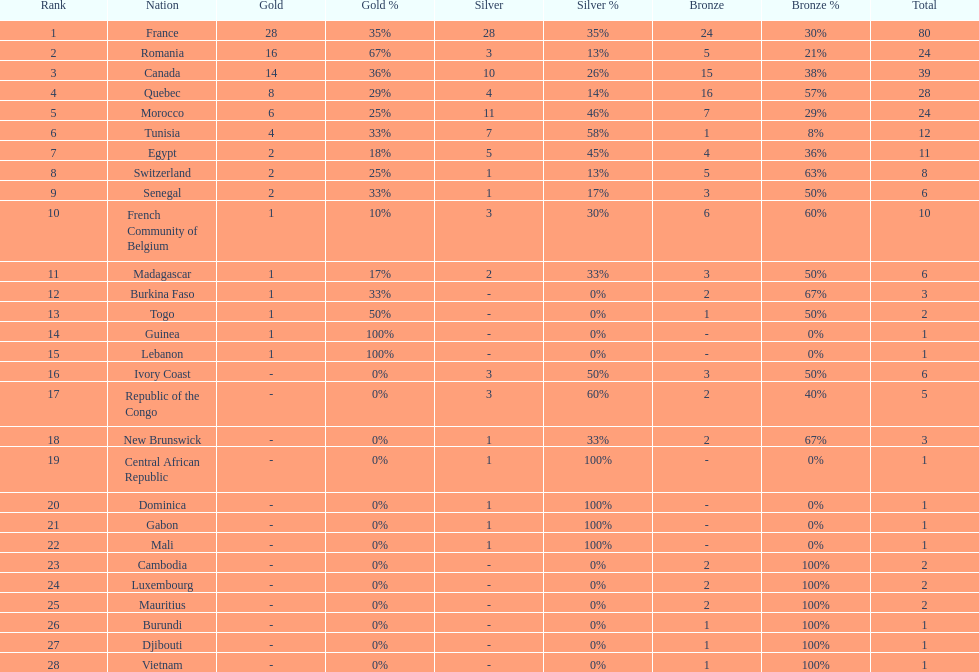How many counties have at least one silver medal? 18. 